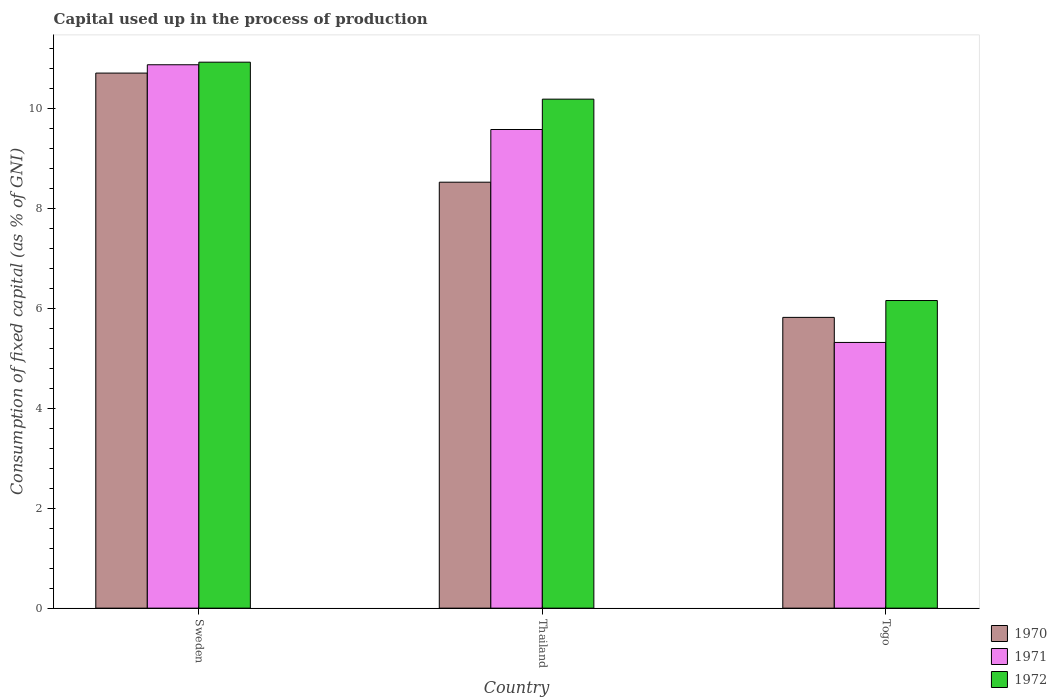How many groups of bars are there?
Your answer should be compact. 3. Are the number of bars per tick equal to the number of legend labels?
Keep it short and to the point. Yes. How many bars are there on the 1st tick from the left?
Keep it short and to the point. 3. What is the label of the 2nd group of bars from the left?
Your response must be concise. Thailand. What is the capital used up in the process of production in 1972 in Togo?
Make the answer very short. 6.16. Across all countries, what is the maximum capital used up in the process of production in 1972?
Your answer should be compact. 10.93. Across all countries, what is the minimum capital used up in the process of production in 1971?
Give a very brief answer. 5.32. In which country was the capital used up in the process of production in 1972 minimum?
Provide a succinct answer. Togo. What is the total capital used up in the process of production in 1970 in the graph?
Ensure brevity in your answer.  25.06. What is the difference between the capital used up in the process of production in 1970 in Sweden and that in Thailand?
Provide a short and direct response. 2.18. What is the difference between the capital used up in the process of production in 1972 in Togo and the capital used up in the process of production in 1970 in Thailand?
Provide a succinct answer. -2.37. What is the average capital used up in the process of production in 1972 per country?
Give a very brief answer. 9.09. What is the difference between the capital used up in the process of production of/in 1971 and capital used up in the process of production of/in 1972 in Thailand?
Ensure brevity in your answer.  -0.61. What is the ratio of the capital used up in the process of production in 1970 in Sweden to that in Togo?
Your answer should be very brief. 1.84. Is the capital used up in the process of production in 1970 in Thailand less than that in Togo?
Your answer should be very brief. No. What is the difference between the highest and the second highest capital used up in the process of production in 1970?
Provide a succinct answer. -2.18. What is the difference between the highest and the lowest capital used up in the process of production in 1972?
Give a very brief answer. 4.77. In how many countries, is the capital used up in the process of production in 1972 greater than the average capital used up in the process of production in 1972 taken over all countries?
Your response must be concise. 2. How many bars are there?
Offer a very short reply. 9. Are all the bars in the graph horizontal?
Keep it short and to the point. No. How many countries are there in the graph?
Provide a succinct answer. 3. Are the values on the major ticks of Y-axis written in scientific E-notation?
Keep it short and to the point. No. Does the graph contain grids?
Make the answer very short. No. Where does the legend appear in the graph?
Your answer should be very brief. Bottom right. How many legend labels are there?
Give a very brief answer. 3. What is the title of the graph?
Provide a succinct answer. Capital used up in the process of production. Does "2000" appear as one of the legend labels in the graph?
Provide a succinct answer. No. What is the label or title of the X-axis?
Your response must be concise. Country. What is the label or title of the Y-axis?
Make the answer very short. Consumption of fixed capital (as % of GNI). What is the Consumption of fixed capital (as % of GNI) of 1970 in Sweden?
Ensure brevity in your answer.  10.71. What is the Consumption of fixed capital (as % of GNI) of 1971 in Sweden?
Your response must be concise. 10.88. What is the Consumption of fixed capital (as % of GNI) in 1972 in Sweden?
Your response must be concise. 10.93. What is the Consumption of fixed capital (as % of GNI) in 1970 in Thailand?
Give a very brief answer. 8.53. What is the Consumption of fixed capital (as % of GNI) of 1971 in Thailand?
Offer a terse response. 9.58. What is the Consumption of fixed capital (as % of GNI) of 1972 in Thailand?
Offer a terse response. 10.19. What is the Consumption of fixed capital (as % of GNI) of 1970 in Togo?
Provide a succinct answer. 5.82. What is the Consumption of fixed capital (as % of GNI) in 1971 in Togo?
Give a very brief answer. 5.32. What is the Consumption of fixed capital (as % of GNI) in 1972 in Togo?
Make the answer very short. 6.16. Across all countries, what is the maximum Consumption of fixed capital (as % of GNI) of 1970?
Ensure brevity in your answer.  10.71. Across all countries, what is the maximum Consumption of fixed capital (as % of GNI) in 1971?
Offer a terse response. 10.88. Across all countries, what is the maximum Consumption of fixed capital (as % of GNI) in 1972?
Your response must be concise. 10.93. Across all countries, what is the minimum Consumption of fixed capital (as % of GNI) of 1970?
Your answer should be compact. 5.82. Across all countries, what is the minimum Consumption of fixed capital (as % of GNI) in 1971?
Your response must be concise. 5.32. Across all countries, what is the minimum Consumption of fixed capital (as % of GNI) in 1972?
Give a very brief answer. 6.16. What is the total Consumption of fixed capital (as % of GNI) of 1970 in the graph?
Offer a very short reply. 25.06. What is the total Consumption of fixed capital (as % of GNI) in 1971 in the graph?
Give a very brief answer. 25.78. What is the total Consumption of fixed capital (as % of GNI) in 1972 in the graph?
Give a very brief answer. 27.28. What is the difference between the Consumption of fixed capital (as % of GNI) of 1970 in Sweden and that in Thailand?
Your response must be concise. 2.18. What is the difference between the Consumption of fixed capital (as % of GNI) of 1971 in Sweden and that in Thailand?
Provide a short and direct response. 1.3. What is the difference between the Consumption of fixed capital (as % of GNI) of 1972 in Sweden and that in Thailand?
Give a very brief answer. 0.74. What is the difference between the Consumption of fixed capital (as % of GNI) of 1970 in Sweden and that in Togo?
Offer a terse response. 4.89. What is the difference between the Consumption of fixed capital (as % of GNI) in 1971 in Sweden and that in Togo?
Provide a short and direct response. 5.56. What is the difference between the Consumption of fixed capital (as % of GNI) in 1972 in Sweden and that in Togo?
Make the answer very short. 4.77. What is the difference between the Consumption of fixed capital (as % of GNI) in 1970 in Thailand and that in Togo?
Make the answer very short. 2.71. What is the difference between the Consumption of fixed capital (as % of GNI) in 1971 in Thailand and that in Togo?
Offer a very short reply. 4.26. What is the difference between the Consumption of fixed capital (as % of GNI) of 1972 in Thailand and that in Togo?
Make the answer very short. 4.03. What is the difference between the Consumption of fixed capital (as % of GNI) of 1970 in Sweden and the Consumption of fixed capital (as % of GNI) of 1971 in Thailand?
Make the answer very short. 1.13. What is the difference between the Consumption of fixed capital (as % of GNI) of 1970 in Sweden and the Consumption of fixed capital (as % of GNI) of 1972 in Thailand?
Give a very brief answer. 0.52. What is the difference between the Consumption of fixed capital (as % of GNI) of 1971 in Sweden and the Consumption of fixed capital (as % of GNI) of 1972 in Thailand?
Give a very brief answer. 0.69. What is the difference between the Consumption of fixed capital (as % of GNI) of 1970 in Sweden and the Consumption of fixed capital (as % of GNI) of 1971 in Togo?
Your response must be concise. 5.39. What is the difference between the Consumption of fixed capital (as % of GNI) in 1970 in Sweden and the Consumption of fixed capital (as % of GNI) in 1972 in Togo?
Make the answer very short. 4.55. What is the difference between the Consumption of fixed capital (as % of GNI) in 1971 in Sweden and the Consumption of fixed capital (as % of GNI) in 1972 in Togo?
Offer a terse response. 4.72. What is the difference between the Consumption of fixed capital (as % of GNI) of 1970 in Thailand and the Consumption of fixed capital (as % of GNI) of 1971 in Togo?
Offer a very short reply. 3.21. What is the difference between the Consumption of fixed capital (as % of GNI) in 1970 in Thailand and the Consumption of fixed capital (as % of GNI) in 1972 in Togo?
Offer a very short reply. 2.37. What is the difference between the Consumption of fixed capital (as % of GNI) of 1971 in Thailand and the Consumption of fixed capital (as % of GNI) of 1972 in Togo?
Provide a succinct answer. 3.42. What is the average Consumption of fixed capital (as % of GNI) of 1970 per country?
Ensure brevity in your answer.  8.35. What is the average Consumption of fixed capital (as % of GNI) in 1971 per country?
Keep it short and to the point. 8.59. What is the average Consumption of fixed capital (as % of GNI) in 1972 per country?
Ensure brevity in your answer.  9.09. What is the difference between the Consumption of fixed capital (as % of GNI) of 1970 and Consumption of fixed capital (as % of GNI) of 1971 in Sweden?
Your answer should be very brief. -0.17. What is the difference between the Consumption of fixed capital (as % of GNI) of 1970 and Consumption of fixed capital (as % of GNI) of 1972 in Sweden?
Keep it short and to the point. -0.22. What is the difference between the Consumption of fixed capital (as % of GNI) of 1971 and Consumption of fixed capital (as % of GNI) of 1972 in Sweden?
Ensure brevity in your answer.  -0.05. What is the difference between the Consumption of fixed capital (as % of GNI) of 1970 and Consumption of fixed capital (as % of GNI) of 1971 in Thailand?
Provide a short and direct response. -1.05. What is the difference between the Consumption of fixed capital (as % of GNI) in 1970 and Consumption of fixed capital (as % of GNI) in 1972 in Thailand?
Provide a succinct answer. -1.66. What is the difference between the Consumption of fixed capital (as % of GNI) of 1971 and Consumption of fixed capital (as % of GNI) of 1972 in Thailand?
Keep it short and to the point. -0.61. What is the difference between the Consumption of fixed capital (as % of GNI) in 1970 and Consumption of fixed capital (as % of GNI) in 1971 in Togo?
Your answer should be compact. 0.5. What is the difference between the Consumption of fixed capital (as % of GNI) of 1970 and Consumption of fixed capital (as % of GNI) of 1972 in Togo?
Offer a terse response. -0.34. What is the difference between the Consumption of fixed capital (as % of GNI) in 1971 and Consumption of fixed capital (as % of GNI) in 1972 in Togo?
Your response must be concise. -0.84. What is the ratio of the Consumption of fixed capital (as % of GNI) in 1970 in Sweden to that in Thailand?
Your answer should be very brief. 1.26. What is the ratio of the Consumption of fixed capital (as % of GNI) of 1971 in Sweden to that in Thailand?
Provide a short and direct response. 1.14. What is the ratio of the Consumption of fixed capital (as % of GNI) of 1972 in Sweden to that in Thailand?
Keep it short and to the point. 1.07. What is the ratio of the Consumption of fixed capital (as % of GNI) of 1970 in Sweden to that in Togo?
Your answer should be very brief. 1.84. What is the ratio of the Consumption of fixed capital (as % of GNI) of 1971 in Sweden to that in Togo?
Offer a terse response. 2.05. What is the ratio of the Consumption of fixed capital (as % of GNI) in 1972 in Sweden to that in Togo?
Ensure brevity in your answer.  1.77. What is the ratio of the Consumption of fixed capital (as % of GNI) in 1970 in Thailand to that in Togo?
Ensure brevity in your answer.  1.47. What is the ratio of the Consumption of fixed capital (as % of GNI) in 1971 in Thailand to that in Togo?
Ensure brevity in your answer.  1.8. What is the ratio of the Consumption of fixed capital (as % of GNI) of 1972 in Thailand to that in Togo?
Provide a short and direct response. 1.65. What is the difference between the highest and the second highest Consumption of fixed capital (as % of GNI) of 1970?
Give a very brief answer. 2.18. What is the difference between the highest and the second highest Consumption of fixed capital (as % of GNI) of 1971?
Your response must be concise. 1.3. What is the difference between the highest and the second highest Consumption of fixed capital (as % of GNI) of 1972?
Keep it short and to the point. 0.74. What is the difference between the highest and the lowest Consumption of fixed capital (as % of GNI) in 1970?
Keep it short and to the point. 4.89. What is the difference between the highest and the lowest Consumption of fixed capital (as % of GNI) of 1971?
Give a very brief answer. 5.56. What is the difference between the highest and the lowest Consumption of fixed capital (as % of GNI) of 1972?
Offer a terse response. 4.77. 